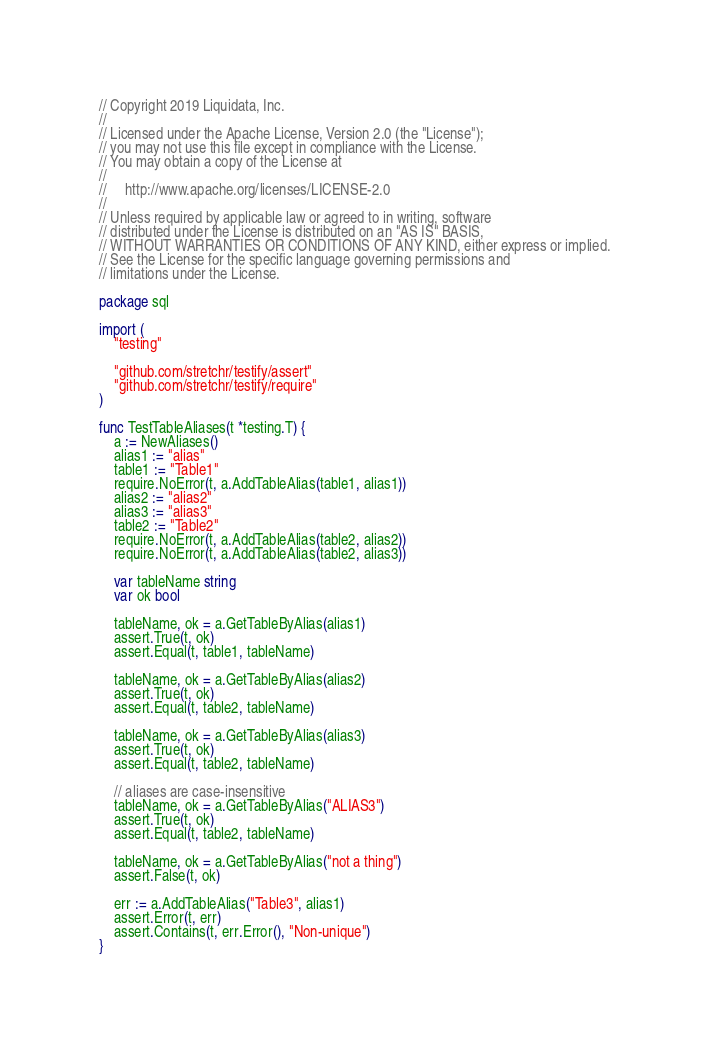<code> <loc_0><loc_0><loc_500><loc_500><_Go_>// Copyright 2019 Liquidata, Inc.
//
// Licensed under the Apache License, Version 2.0 (the "License");
// you may not use this file except in compliance with the License.
// You may obtain a copy of the License at
//
//     http://www.apache.org/licenses/LICENSE-2.0
//
// Unless required by applicable law or agreed to in writing, software
// distributed under the License is distributed on an "AS IS" BASIS,
// WITHOUT WARRANTIES OR CONDITIONS OF ANY KIND, either express or implied.
// See the License for the specific language governing permissions and
// limitations under the License.

package sql

import (
	"testing"

	"github.com/stretchr/testify/assert"
	"github.com/stretchr/testify/require"
)

func TestTableAliases(t *testing.T) {
	a := NewAliases()
	alias1 := "alias"
	table1 := "Table1"
	require.NoError(t, a.AddTableAlias(table1, alias1))
	alias2 := "alias2"
	alias3 := "alias3"
	table2 := "Table2"
	require.NoError(t, a.AddTableAlias(table2, alias2))
	require.NoError(t, a.AddTableAlias(table2, alias3))

	var tableName string
	var ok bool

	tableName, ok = a.GetTableByAlias(alias1)
	assert.True(t, ok)
	assert.Equal(t, table1, tableName)

	tableName, ok = a.GetTableByAlias(alias2)
	assert.True(t, ok)
	assert.Equal(t, table2, tableName)

	tableName, ok = a.GetTableByAlias(alias3)
	assert.True(t, ok)
	assert.Equal(t, table2, tableName)

	// aliases are case-insensitive
	tableName, ok = a.GetTableByAlias("ALIAS3")
	assert.True(t, ok)
	assert.Equal(t, table2, tableName)

	tableName, ok = a.GetTableByAlias("not a thing")
	assert.False(t, ok)

	err := a.AddTableAlias("Table3", alias1)
	assert.Error(t, err)
	assert.Contains(t, err.Error(), "Non-unique")
}
</code> 